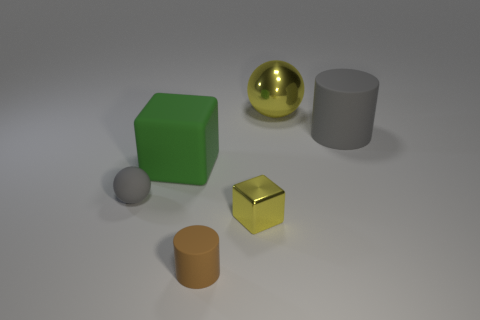Do the tiny brown matte object and the big yellow metallic object have the same shape?
Ensure brevity in your answer.  No. There is a green matte block; are there any small spheres behind it?
Keep it short and to the point. No. Is the number of brown rubber cylinders that are behind the large matte cube the same as the number of large red rubber things?
Provide a succinct answer. Yes. What size is the other thing that is the same shape as the green object?
Your response must be concise. Small. Is the shape of the small yellow thing the same as the object to the right of the big yellow thing?
Make the answer very short. No. There is a metal object that is behind the gray rubber thing that is to the left of the tiny yellow block; what size is it?
Your response must be concise. Large. Are there the same number of large gray matte cylinders that are behind the shiny sphere and brown matte cylinders that are to the left of the green cube?
Keep it short and to the point. Yes. There is another object that is the same shape as the big metal object; what color is it?
Ensure brevity in your answer.  Gray. How many metallic spheres are the same color as the big rubber cube?
Keep it short and to the point. 0. Is the shape of the tiny yellow object that is in front of the big yellow ball the same as  the brown matte thing?
Keep it short and to the point. No. 